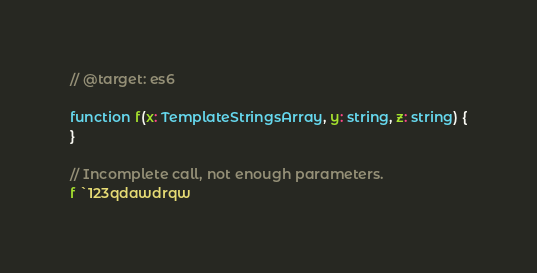Convert code to text. <code><loc_0><loc_0><loc_500><loc_500><_TypeScript_>// @target: es6

function f(x: TemplateStringsArray, y: string, z: string) {
}

// Incomplete call, not enough parameters.
f `123qdawdrqw</code> 